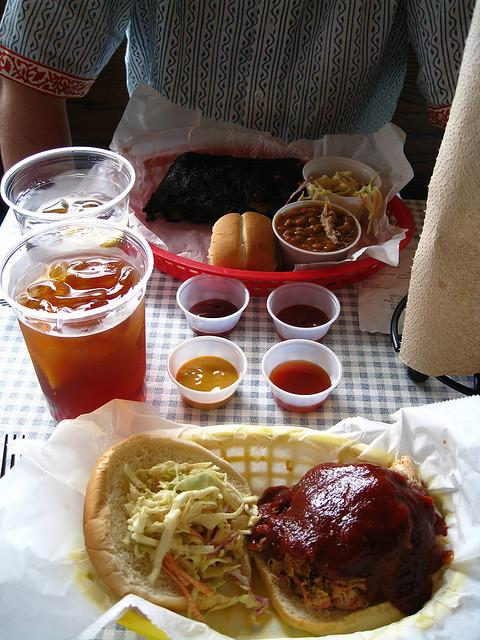What type of sandwich is being served?

Choices:
A) club
B) peanut butter
C) barbeque
D) tuna barbeque 